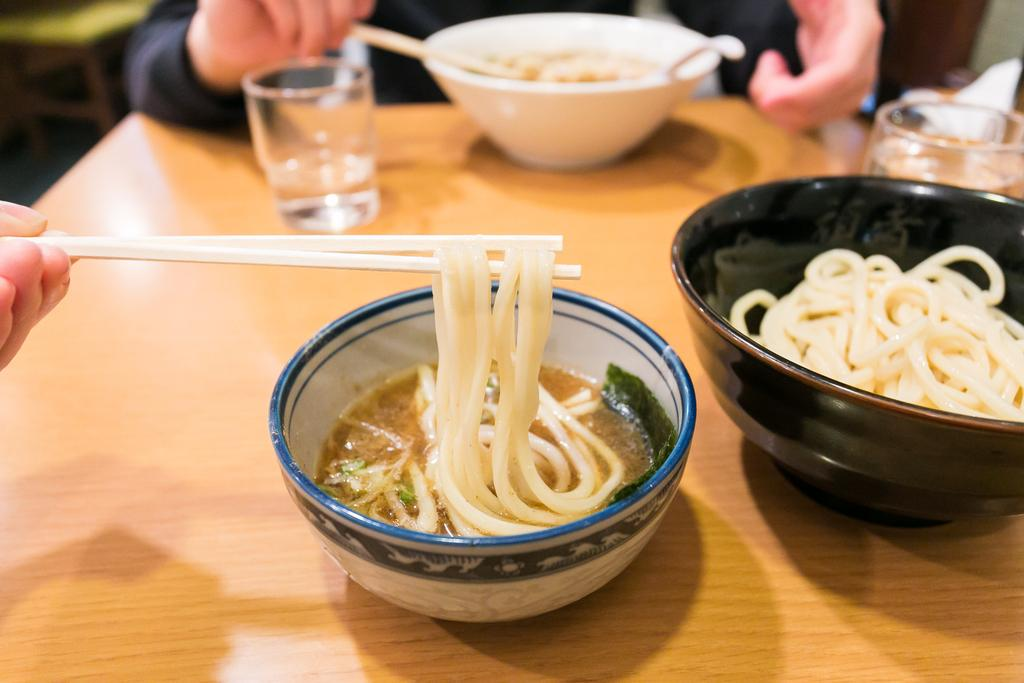How many bowls are visible in the image? There are three bowls in the image. What other tableware can be seen in the image? There are two glasses visible in the image. Where are the bowls and glasses located? The bowls and glasses are on a table. Who is present in the image? There are two people in the image. What are the people holding in their hands? The people are holding chopsticks in their hands. What type of corn is being served in the image? There is no corn present in the image. What is the pancake's flavor in the image? There is no pancake present in the image. 